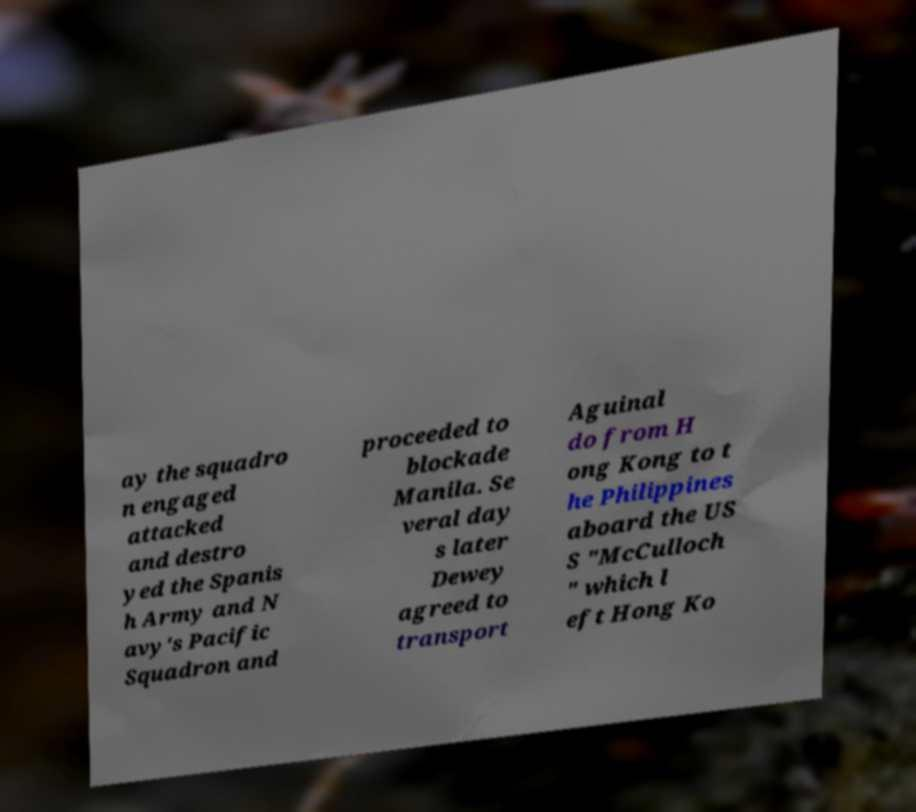Please read and relay the text visible in this image. What does it say? ay the squadro n engaged attacked and destro yed the Spanis h Army and N avy's Pacific Squadron and proceeded to blockade Manila. Se veral day s later Dewey agreed to transport Aguinal do from H ong Kong to t he Philippines aboard the US S "McCulloch " which l eft Hong Ko 